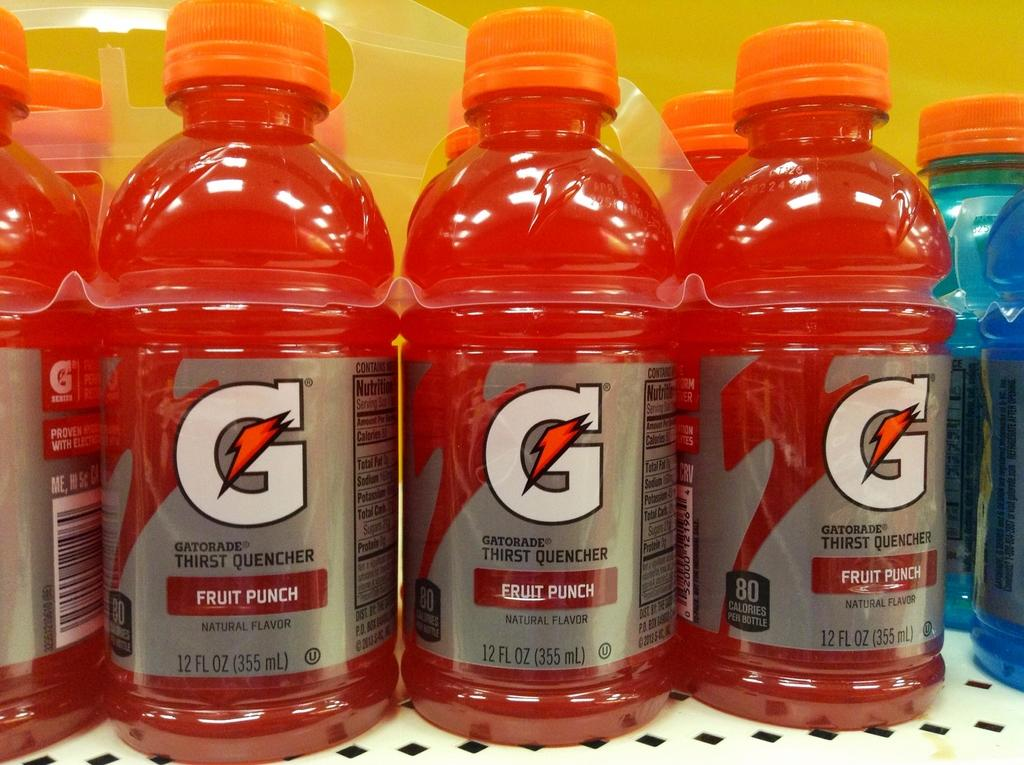What type of beverage containers are present in the image? There are juice bottles in the image. What color are the juice bottles? The juice bottles are red in color. How many boats can be seen sailing in harmony with the zebra in the image? There are no boats or zebras present in the image; it only features red juice bottles. 